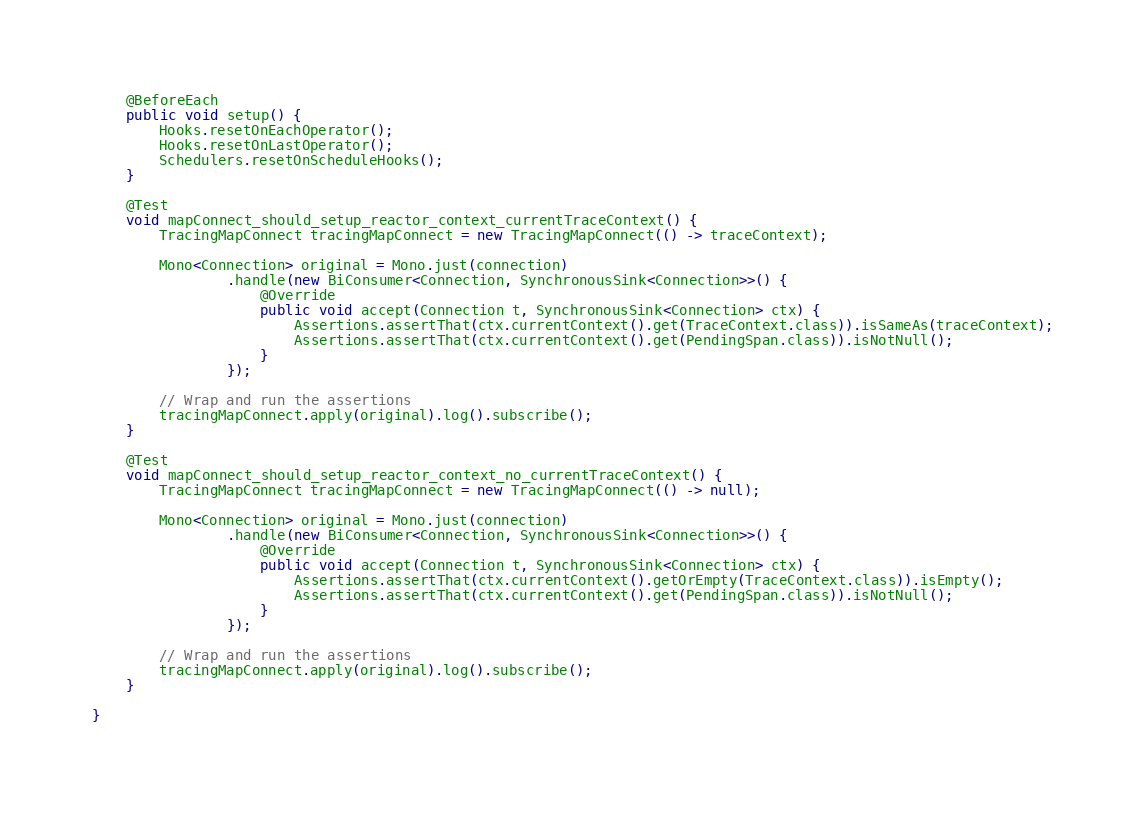<code> <loc_0><loc_0><loc_500><loc_500><_Java_>
	@BeforeEach
	public void setup() {
		Hooks.resetOnEachOperator();
		Hooks.resetOnLastOperator();
		Schedulers.resetOnScheduleHooks();
	}

	@Test
	void mapConnect_should_setup_reactor_context_currentTraceContext() {
		TracingMapConnect tracingMapConnect = new TracingMapConnect(() -> traceContext);

		Mono<Connection> original = Mono.just(connection)
				.handle(new BiConsumer<Connection, SynchronousSink<Connection>>() {
					@Override
					public void accept(Connection t, SynchronousSink<Connection> ctx) {
						Assertions.assertThat(ctx.currentContext().get(TraceContext.class)).isSameAs(traceContext);
						Assertions.assertThat(ctx.currentContext().get(PendingSpan.class)).isNotNull();
					}
				});

		// Wrap and run the assertions
		tracingMapConnect.apply(original).log().subscribe();
	}

	@Test
	void mapConnect_should_setup_reactor_context_no_currentTraceContext() {
		TracingMapConnect tracingMapConnect = new TracingMapConnect(() -> null);

		Mono<Connection> original = Mono.just(connection)
				.handle(new BiConsumer<Connection, SynchronousSink<Connection>>() {
					@Override
					public void accept(Connection t, SynchronousSink<Connection> ctx) {
						Assertions.assertThat(ctx.currentContext().getOrEmpty(TraceContext.class)).isEmpty();
						Assertions.assertThat(ctx.currentContext().get(PendingSpan.class)).isNotNull();
					}
				});

		// Wrap and run the assertions
		tracingMapConnect.apply(original).log().subscribe();
	}

}
</code> 